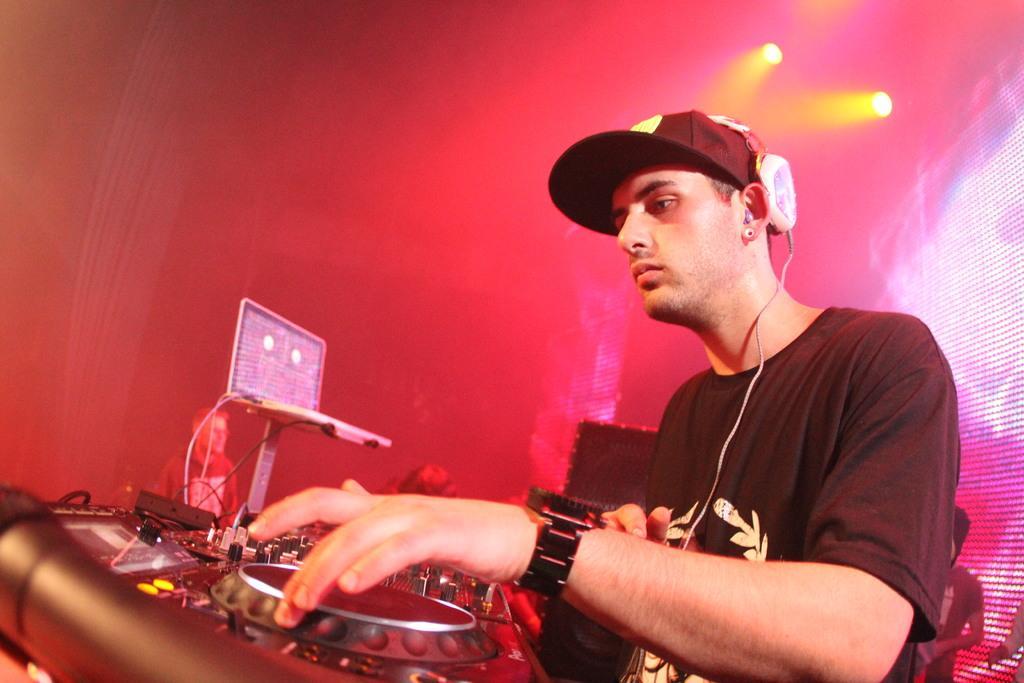Can you describe this image briefly? In this picture we can see a man operating a music controller, he wore a cap and headphones, we can see lights here. 